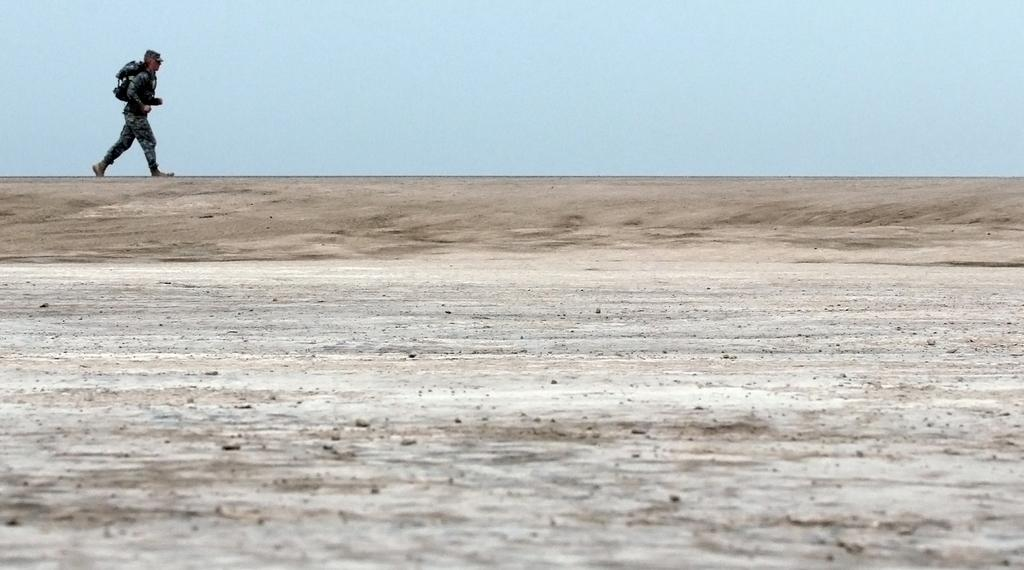What is the main subject of the image? A: The main subject of the image is a soldier. Where is the soldier located in the image? The soldier is on the top left side of the image. What is the soldier doing in the image? The soldier is walking on a road. What is the condition of the sky in the image? The sky is clear in the image. What type of metal can be seen in the soldier's pocket in the image? There is no mention of any metal or pockets in the provided facts, and therefore we cannot determine if there is any metal present in the soldier's pocket. 